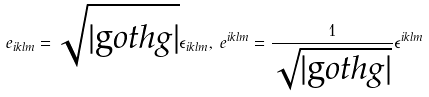Convert formula to latex. <formula><loc_0><loc_0><loc_500><loc_500>e _ { i k l m } = \sqrt { | \text  goth{g} | } \epsilon _ { i k l m } , \, e ^ { i k l m } = \frac { 1 } { \sqrt { | \text  goth{g} | } } \epsilon ^ { i k l m }</formula> 